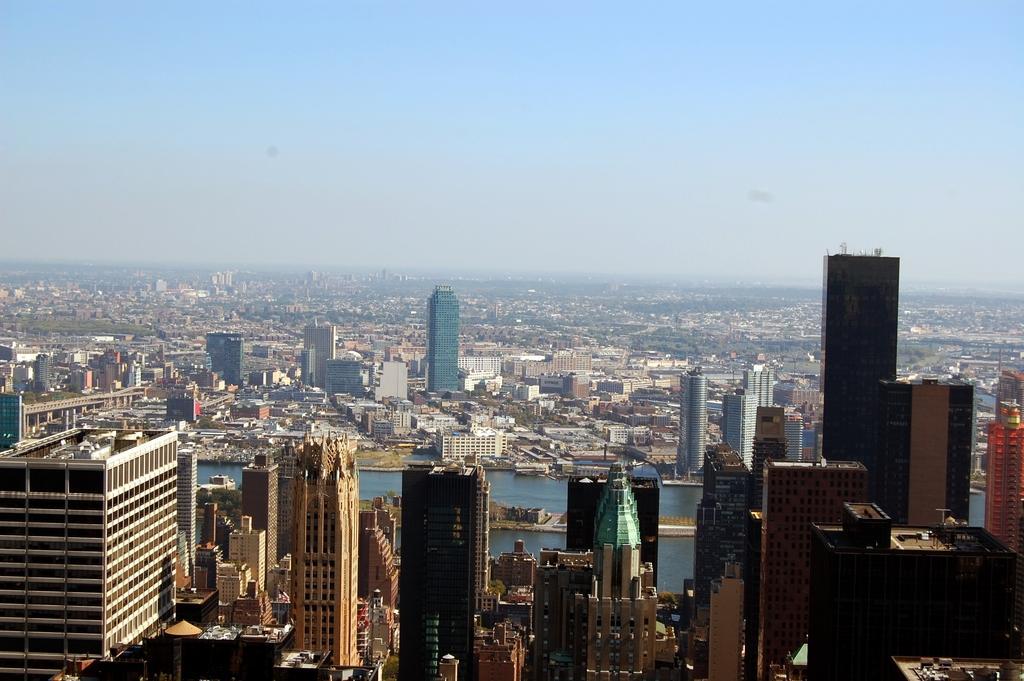Can you describe this image briefly? In the image we can see there are lot of huge buildings and there is river in between the buildings. There is a clear sky. 